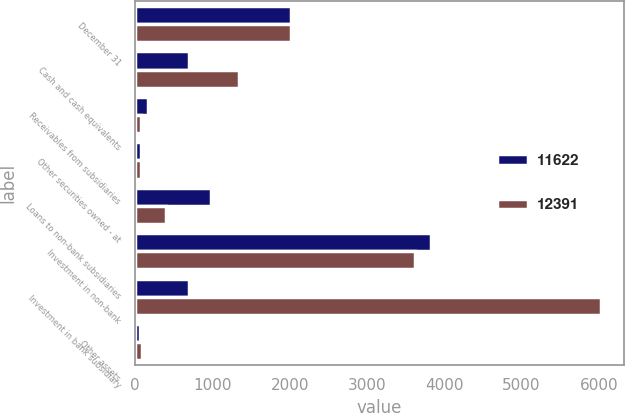<chart> <loc_0><loc_0><loc_500><loc_500><stacked_bar_chart><ecel><fcel>December 31<fcel>Cash and cash equivalents<fcel>Receivables from subsidiaries<fcel>Other securities owned - at<fcel>Loans to non-bank subsidiaries<fcel>Investment in non-bank<fcel>Investment in bank subsidiary<fcel>Other assets<nl><fcel>11622<fcel>2013<fcel>700<fcel>162<fcel>80<fcel>980<fcel>3828<fcel>700<fcel>65<nl><fcel>12391<fcel>2012<fcel>1339<fcel>80<fcel>74<fcel>404<fcel>3615<fcel>6022<fcel>88<nl></chart> 